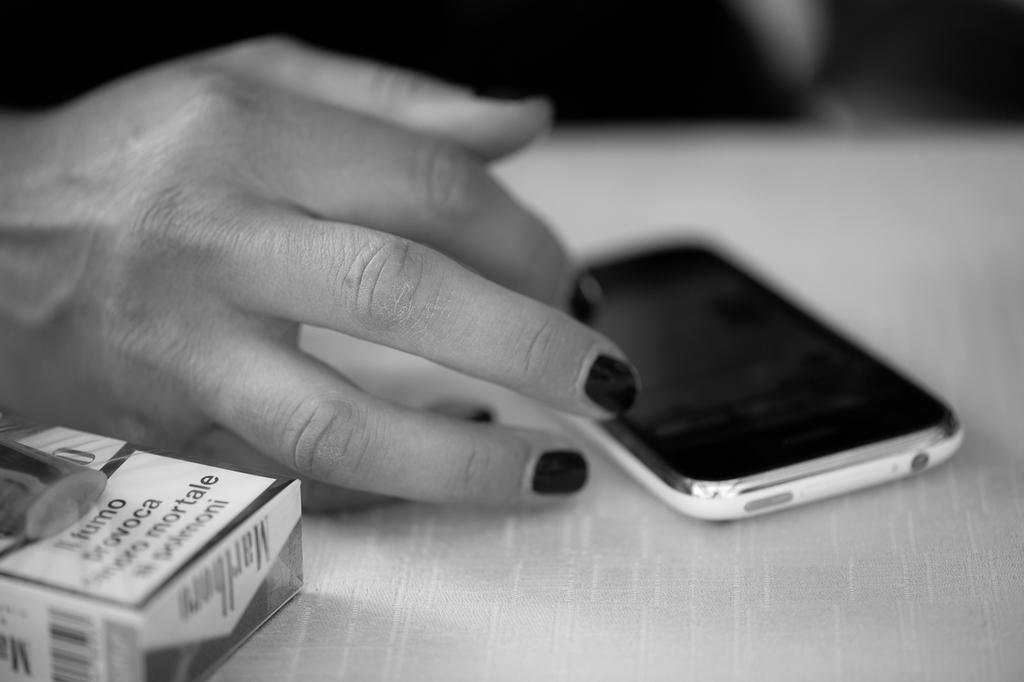In one or two sentences, can you explain what this image depicts? This is a black and white picture, in this image we can see a mobile phone and a box on the table, also we can see a person's hand. 